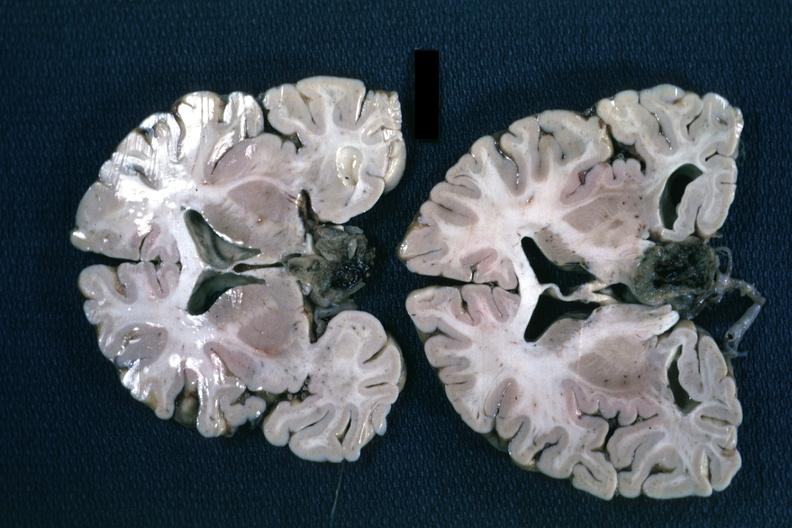s stillborn cord around neck present?
Answer the question using a single word or phrase. No 